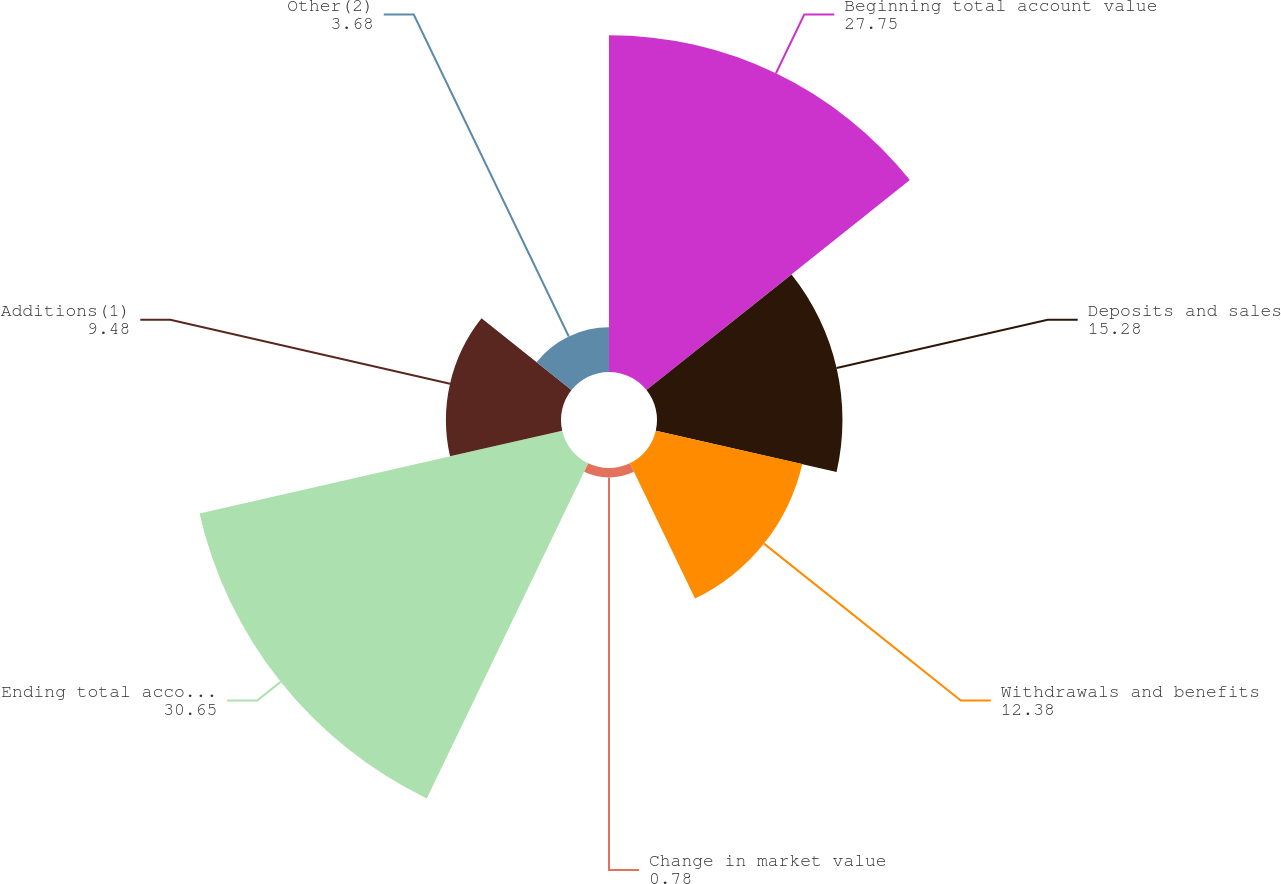Convert chart. <chart><loc_0><loc_0><loc_500><loc_500><pie_chart><fcel>Beginning total account value<fcel>Deposits and sales<fcel>Withdrawals and benefits<fcel>Change in market value<fcel>Ending total account value<fcel>Additions(1)<fcel>Other(2)<nl><fcel>27.75%<fcel>15.28%<fcel>12.38%<fcel>0.78%<fcel>30.65%<fcel>9.48%<fcel>3.68%<nl></chart> 